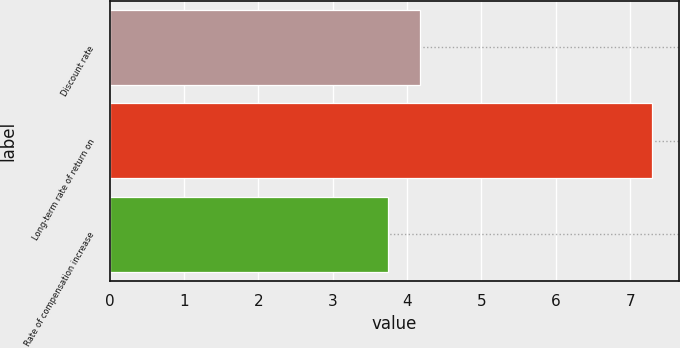<chart> <loc_0><loc_0><loc_500><loc_500><bar_chart><fcel>Discount rate<fcel>Long-term rate of return on<fcel>Rate of compensation increase<nl><fcel>4.17<fcel>7.29<fcel>3.74<nl></chart> 